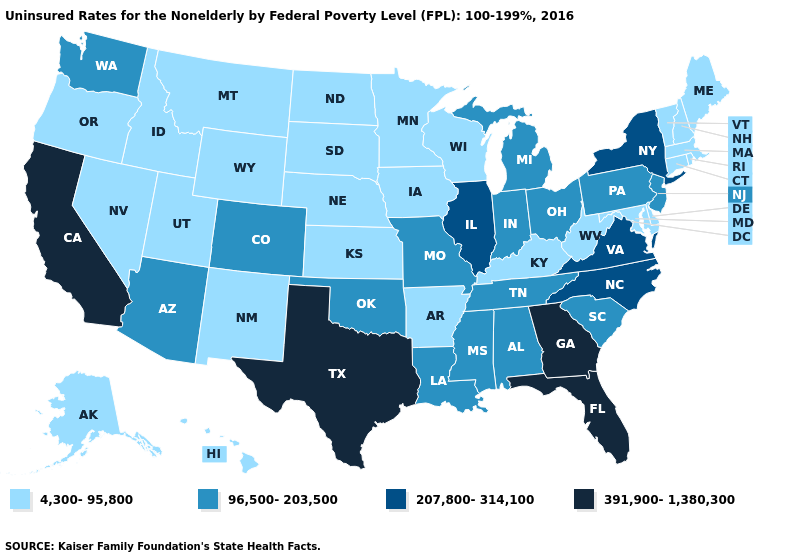Is the legend a continuous bar?
Be succinct. No. Name the states that have a value in the range 96,500-203,500?
Quick response, please. Alabama, Arizona, Colorado, Indiana, Louisiana, Michigan, Mississippi, Missouri, New Jersey, Ohio, Oklahoma, Pennsylvania, South Carolina, Tennessee, Washington. What is the highest value in the West ?
Write a very short answer. 391,900-1,380,300. What is the value of Wisconsin?
Short answer required. 4,300-95,800. Which states have the highest value in the USA?
Short answer required. California, Florida, Georgia, Texas. Is the legend a continuous bar?
Answer briefly. No. Does Kentucky have the lowest value in the South?
Concise answer only. Yes. How many symbols are there in the legend?
Be succinct. 4. Name the states that have a value in the range 96,500-203,500?
Write a very short answer. Alabama, Arizona, Colorado, Indiana, Louisiana, Michigan, Mississippi, Missouri, New Jersey, Ohio, Oklahoma, Pennsylvania, South Carolina, Tennessee, Washington. Which states have the lowest value in the South?
Be succinct. Arkansas, Delaware, Kentucky, Maryland, West Virginia. Among the states that border Kansas , which have the lowest value?
Quick response, please. Nebraska. Which states hav the highest value in the South?
Quick response, please. Florida, Georgia, Texas. What is the value of Nebraska?
Keep it brief. 4,300-95,800. Name the states that have a value in the range 96,500-203,500?
Be succinct. Alabama, Arizona, Colorado, Indiana, Louisiana, Michigan, Mississippi, Missouri, New Jersey, Ohio, Oklahoma, Pennsylvania, South Carolina, Tennessee, Washington. 